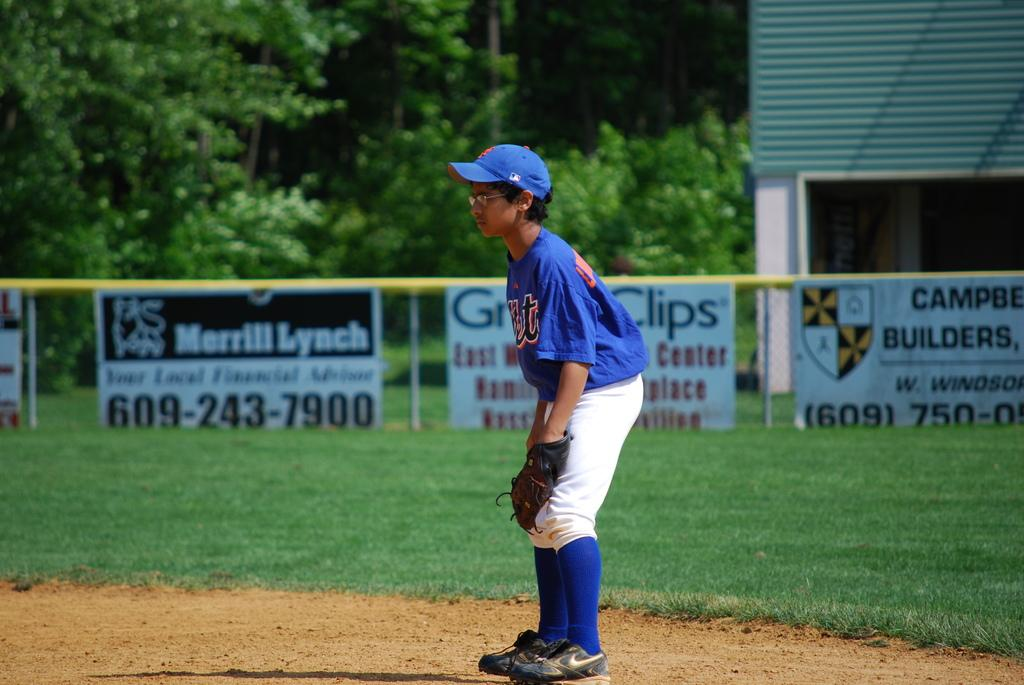<image>
Present a compact description of the photo's key features. A child plays base with Great Clips and Merrill Lynch signs in the background 